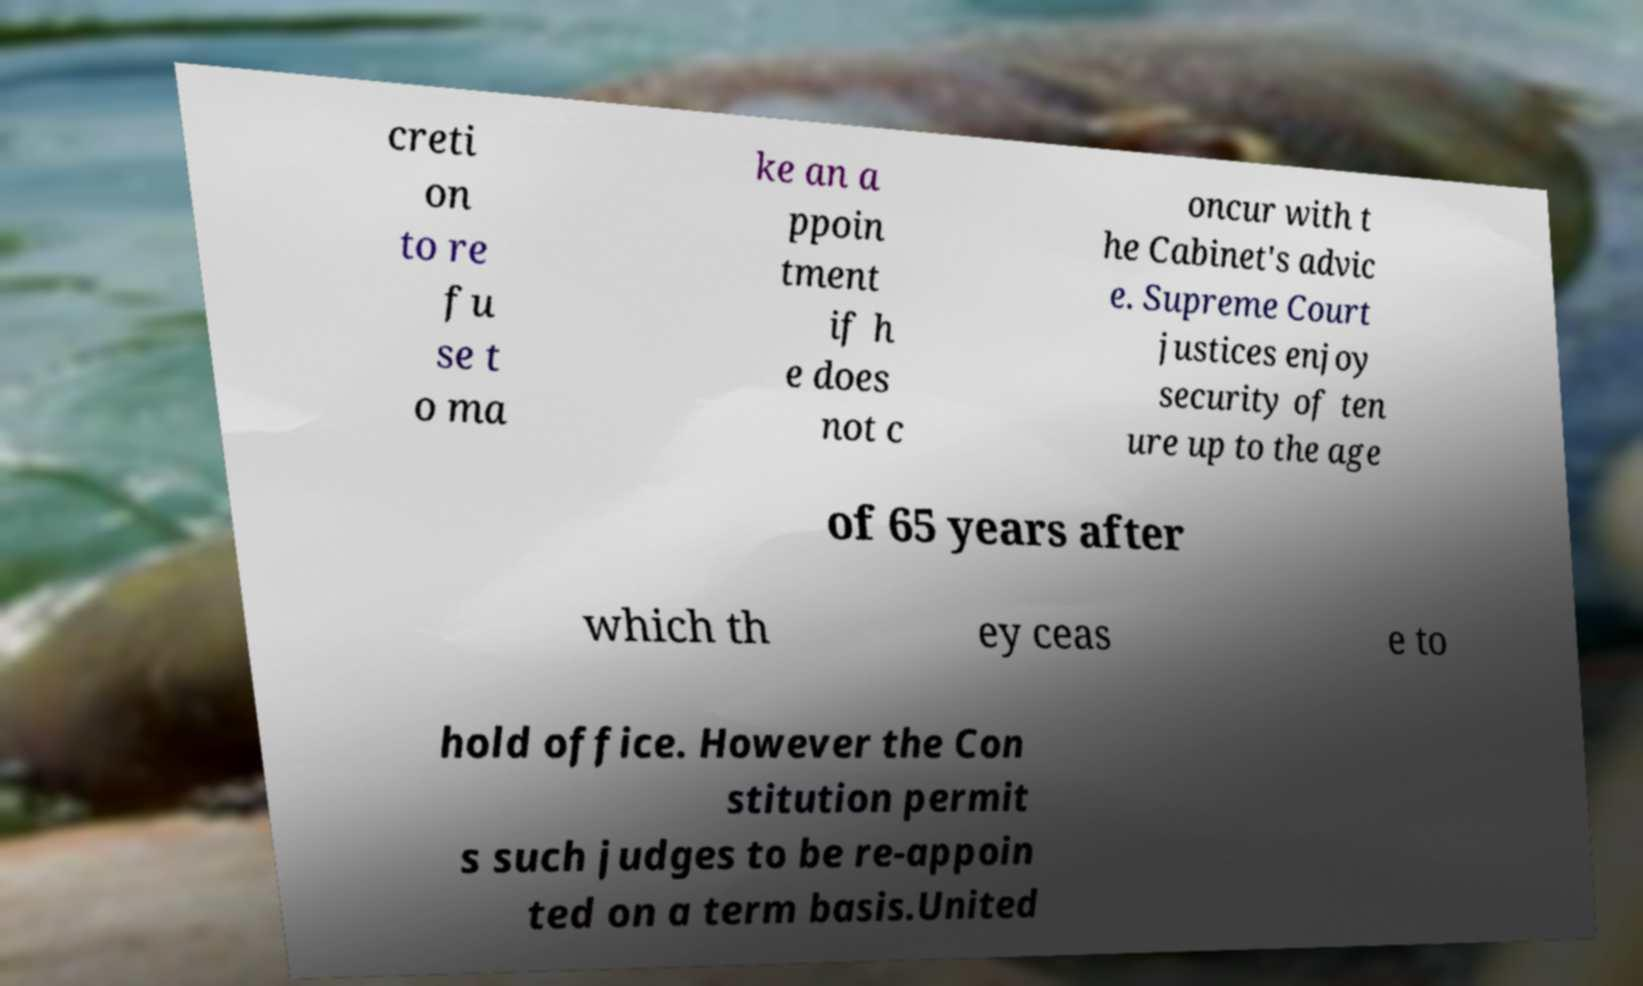I need the written content from this picture converted into text. Can you do that? creti on to re fu se t o ma ke an a ppoin tment if h e does not c oncur with t he Cabinet's advic e. Supreme Court justices enjoy security of ten ure up to the age of 65 years after which th ey ceas e to hold office. However the Con stitution permit s such judges to be re-appoin ted on a term basis.United 